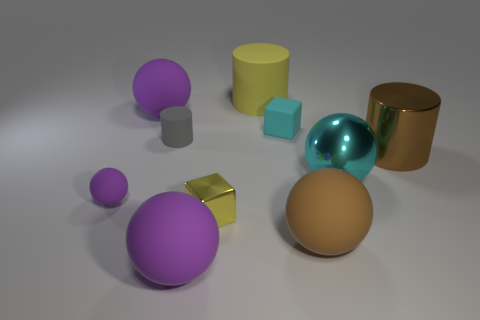Subtract all large brown cylinders. How many cylinders are left? 2 Subtract all cyan cubes. How many purple spheres are left? 3 Subtract all yellow cylinders. How many cylinders are left? 2 Subtract all blue cylinders. Subtract all yellow blocks. How many cylinders are left? 3 Subtract all cylinders. How many objects are left? 7 Subtract all big purple matte balls. Subtract all cyan rubber objects. How many objects are left? 7 Add 5 large cyan things. How many large cyan things are left? 6 Add 2 big brown matte balls. How many big brown matte balls exist? 3 Subtract 0 blue cubes. How many objects are left? 10 